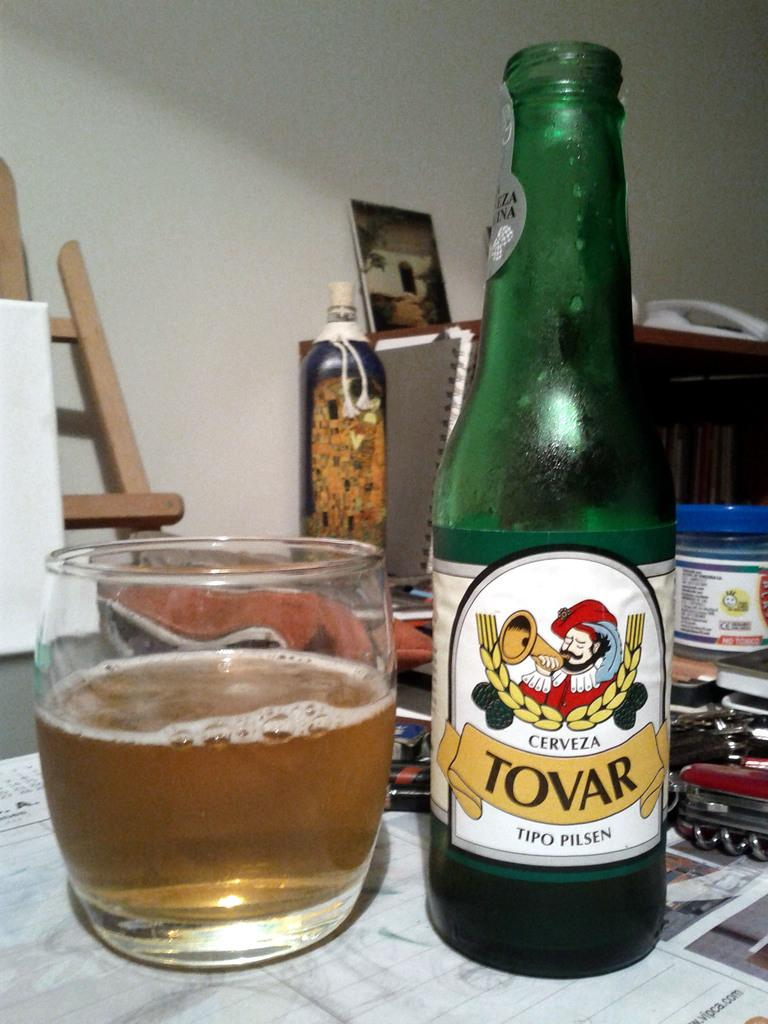<image>
Summarize the visual content of the image. A beer bottle appears that is open and is from the brand Tovar. 